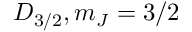Convert formula to latex. <formula><loc_0><loc_0><loc_500><loc_500>D _ { 3 / 2 } , m _ { J } = 3 / 2</formula> 